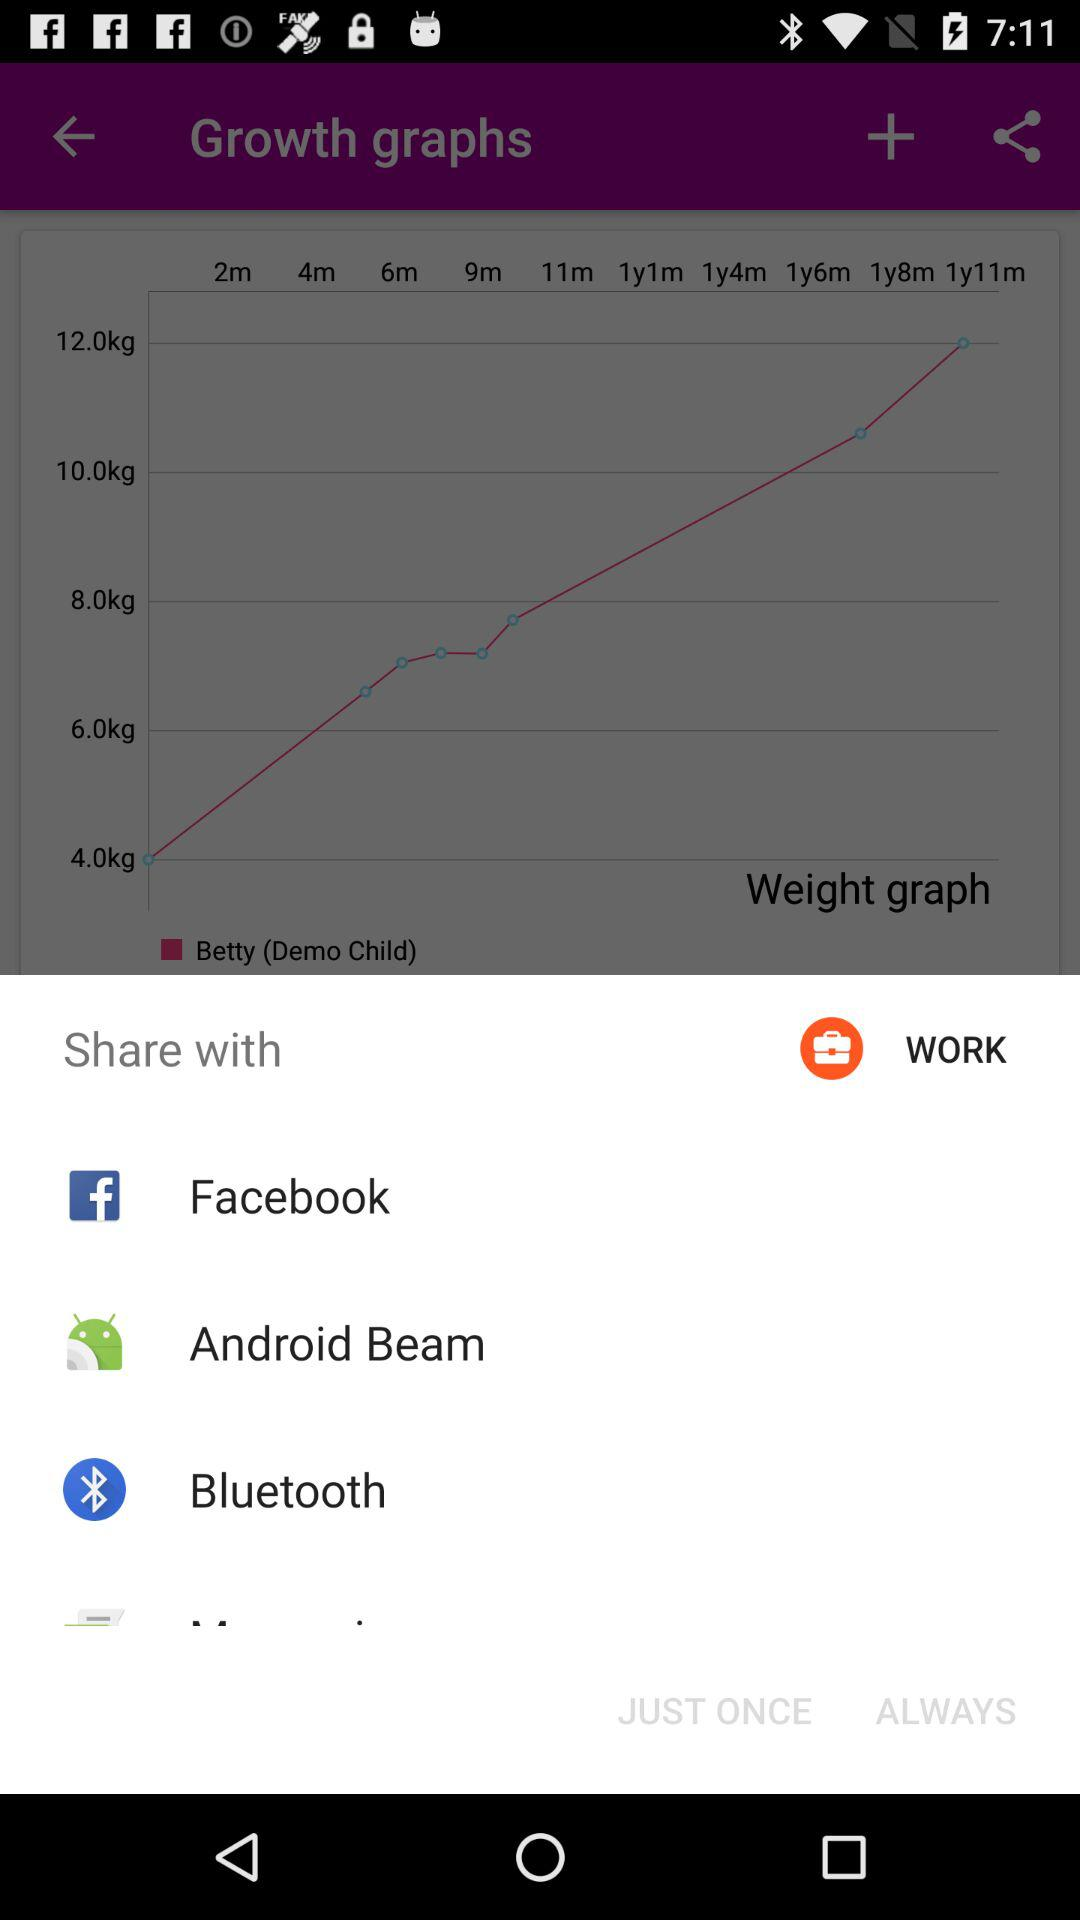How many months are there between 4m and 1y1m?
Answer the question using a single word or phrase. 9 